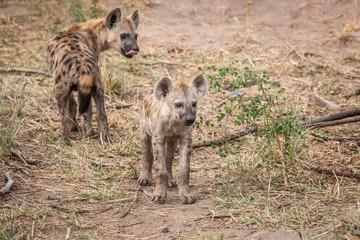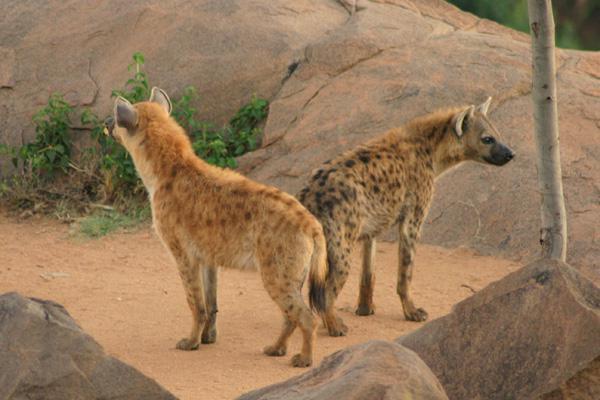The first image is the image on the left, the second image is the image on the right. Assess this claim about the two images: "There are 2 animals facing opposite directions in the right image.". Correct or not? Answer yes or no. Yes. The first image is the image on the left, the second image is the image on the right. Examine the images to the left and right. Is the description "There are a total of 3 hyena's." accurate? Answer yes or no. No. 